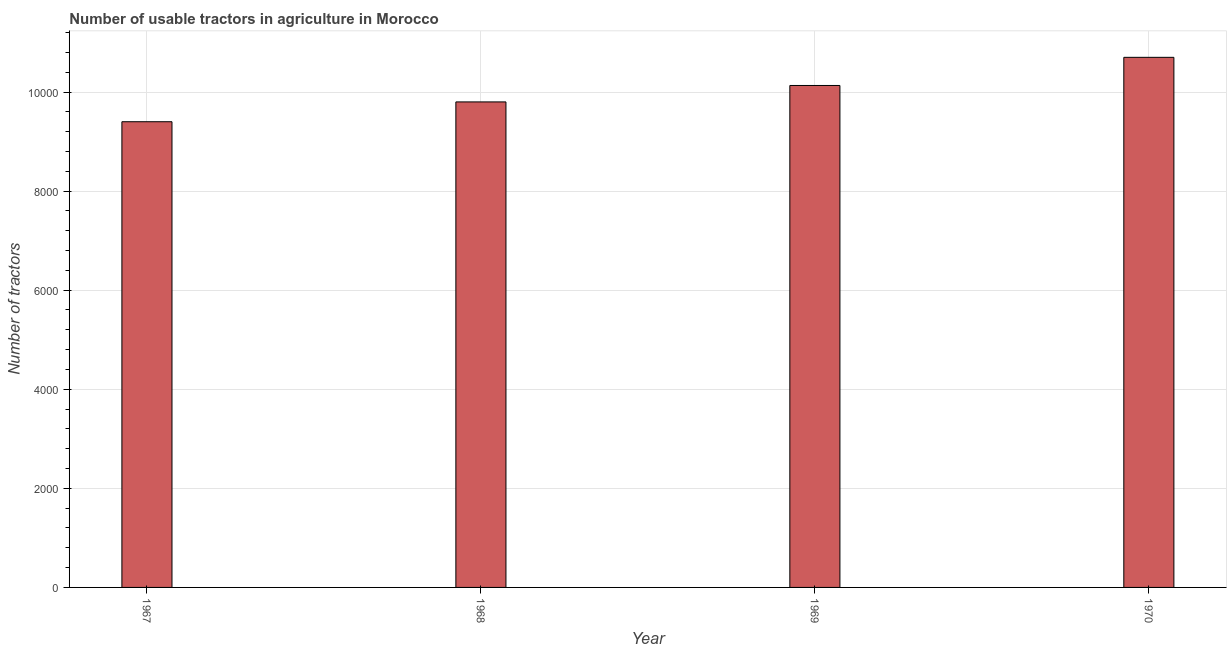Does the graph contain any zero values?
Keep it short and to the point. No. What is the title of the graph?
Your answer should be very brief. Number of usable tractors in agriculture in Morocco. What is the label or title of the Y-axis?
Provide a short and direct response. Number of tractors. What is the number of tractors in 1967?
Your answer should be compact. 9400. Across all years, what is the maximum number of tractors?
Provide a succinct answer. 1.07e+04. Across all years, what is the minimum number of tractors?
Offer a very short reply. 9400. In which year was the number of tractors minimum?
Give a very brief answer. 1967. What is the sum of the number of tractors?
Provide a succinct answer. 4.00e+04. What is the difference between the number of tractors in 1968 and 1970?
Your answer should be very brief. -900. What is the average number of tractors per year?
Provide a short and direct response. 1.00e+04. What is the median number of tractors?
Your answer should be compact. 9966. Do a majority of the years between 1969 and 1970 (inclusive) have number of tractors greater than 3600 ?
Provide a short and direct response. Yes. What is the ratio of the number of tractors in 1968 to that in 1969?
Give a very brief answer. 0.97. Is the difference between the number of tractors in 1969 and 1970 greater than the difference between any two years?
Provide a succinct answer. No. What is the difference between the highest and the second highest number of tractors?
Offer a very short reply. 568. Is the sum of the number of tractors in 1967 and 1969 greater than the maximum number of tractors across all years?
Keep it short and to the point. Yes. What is the difference between the highest and the lowest number of tractors?
Your answer should be very brief. 1300. Are all the bars in the graph horizontal?
Your response must be concise. No. How many years are there in the graph?
Provide a short and direct response. 4. What is the Number of tractors in 1967?
Provide a short and direct response. 9400. What is the Number of tractors of 1968?
Your answer should be very brief. 9800. What is the Number of tractors of 1969?
Keep it short and to the point. 1.01e+04. What is the Number of tractors of 1970?
Keep it short and to the point. 1.07e+04. What is the difference between the Number of tractors in 1967 and 1968?
Ensure brevity in your answer.  -400. What is the difference between the Number of tractors in 1967 and 1969?
Provide a succinct answer. -732. What is the difference between the Number of tractors in 1967 and 1970?
Give a very brief answer. -1300. What is the difference between the Number of tractors in 1968 and 1969?
Offer a very short reply. -332. What is the difference between the Number of tractors in 1968 and 1970?
Keep it short and to the point. -900. What is the difference between the Number of tractors in 1969 and 1970?
Your answer should be compact. -568. What is the ratio of the Number of tractors in 1967 to that in 1968?
Offer a terse response. 0.96. What is the ratio of the Number of tractors in 1967 to that in 1969?
Your answer should be very brief. 0.93. What is the ratio of the Number of tractors in 1967 to that in 1970?
Make the answer very short. 0.88. What is the ratio of the Number of tractors in 1968 to that in 1970?
Give a very brief answer. 0.92. What is the ratio of the Number of tractors in 1969 to that in 1970?
Your answer should be compact. 0.95. 